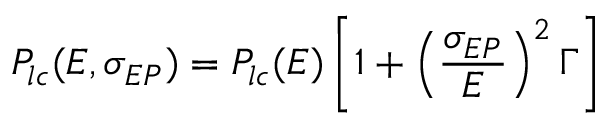<formula> <loc_0><loc_0><loc_500><loc_500>P _ { l c } ( E , \sigma _ { E P } ) = P _ { l c } ( E ) \left [ 1 + \left ( \frac { \sigma _ { E P } } { E } \right ) ^ { 2 } \Gamma \right ] \,</formula> 